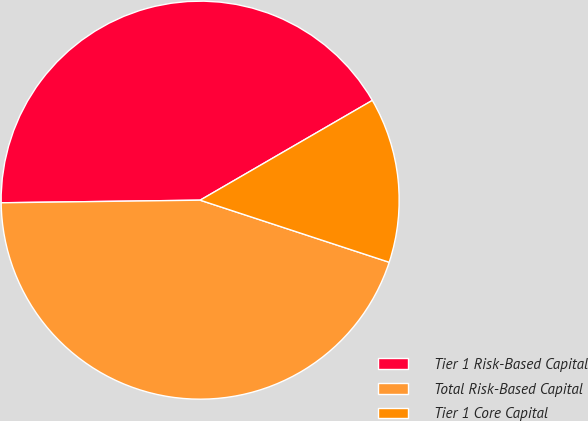Convert chart. <chart><loc_0><loc_0><loc_500><loc_500><pie_chart><fcel>Tier 1 Risk-Based Capital<fcel>Total Risk-Based Capital<fcel>Tier 1 Core Capital<nl><fcel>41.85%<fcel>44.74%<fcel>13.41%<nl></chart> 